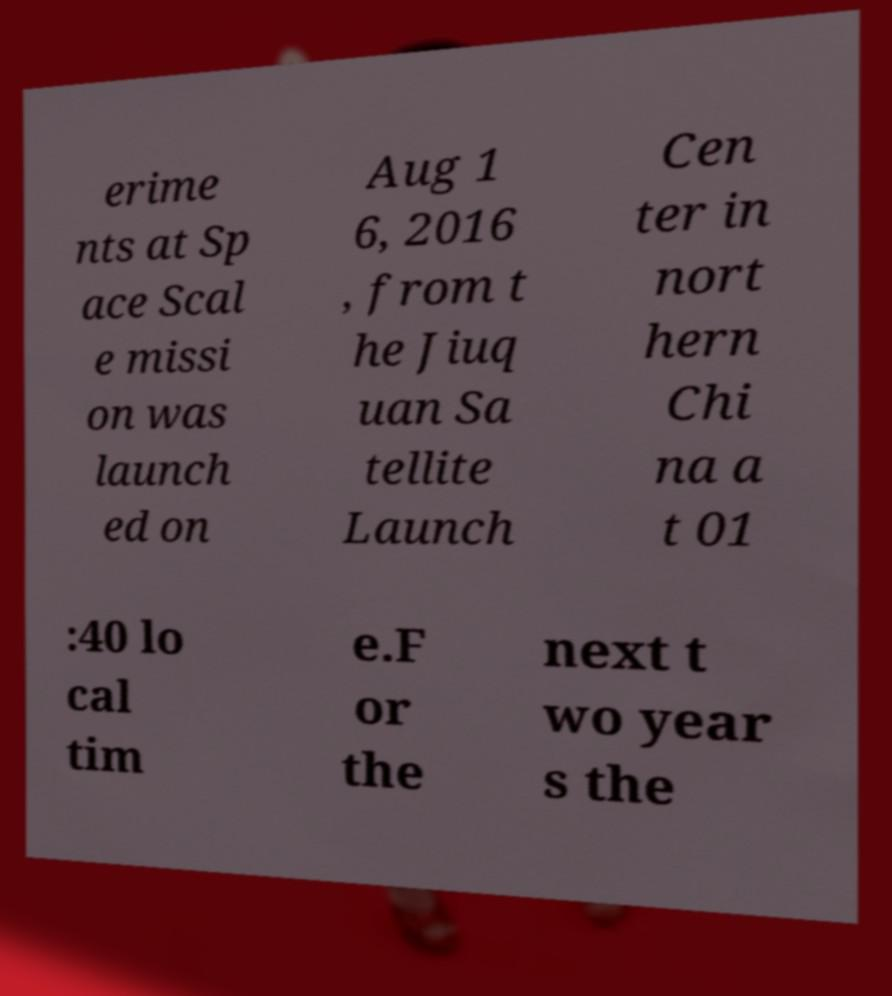Please identify and transcribe the text found in this image. erime nts at Sp ace Scal e missi on was launch ed on Aug 1 6, 2016 , from t he Jiuq uan Sa tellite Launch Cen ter in nort hern Chi na a t 01 :40 lo cal tim e.F or the next t wo year s the 